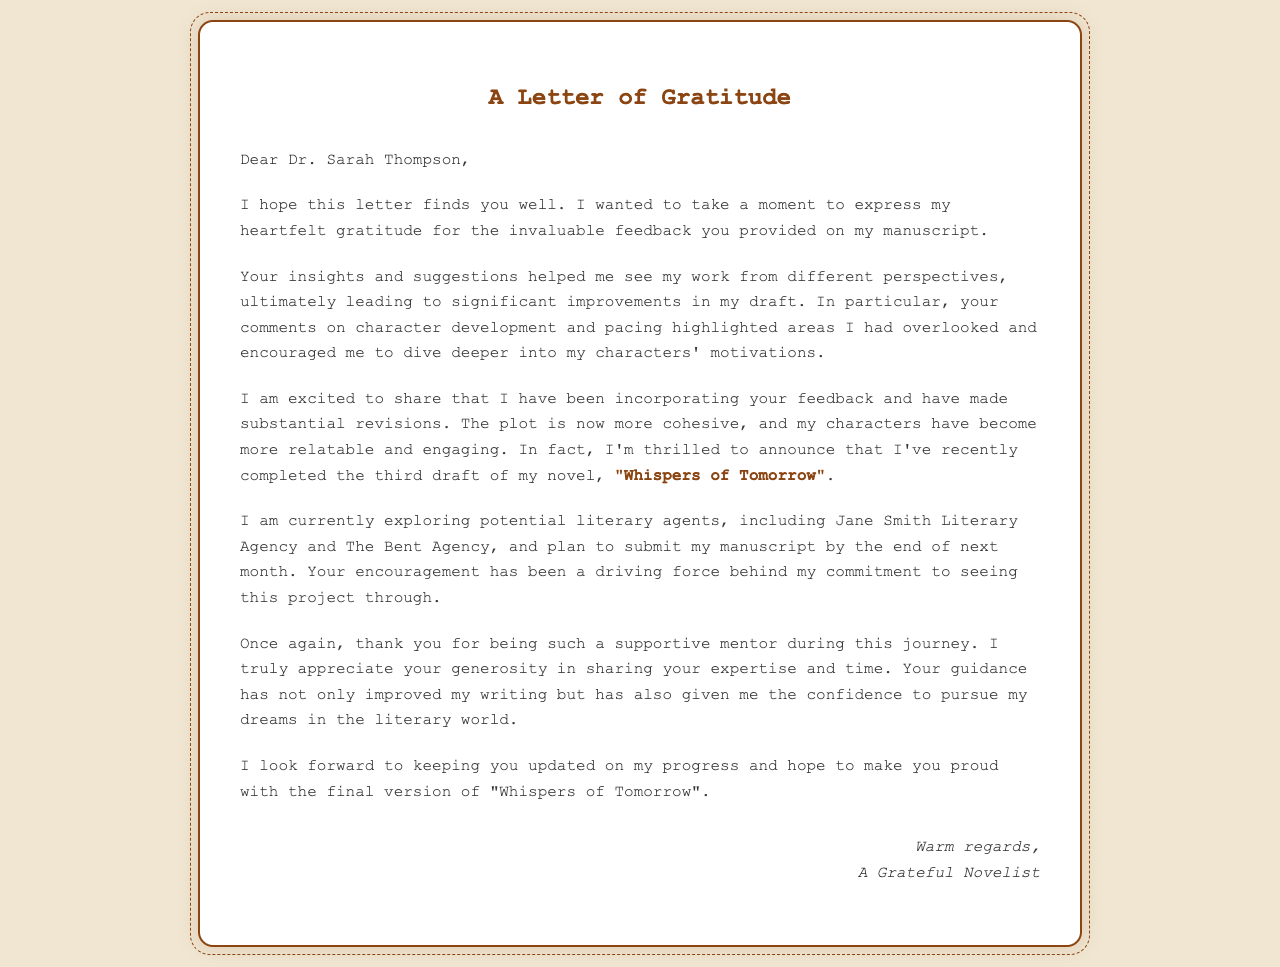What is the name of the mentor? The mentor's name is mentioned in the salutation of the letter.
Answer: Dr. Sarah Thompson What is the title of the manuscript? The title of the manuscript is highlighted in the document as part of the discussion about revisions.
Answer: "Whispers of Tomorrow" How many drafts of the novel have been completed? The letter states how many drafts have been completed, reflecting the author's progress.
Answer: third draft What agencies is the author exploring for representation? The author lists potential literary agencies that they are considering for submission.
Answer: Jane Smith Literary Agency and The Bent Agency What aspect of writing did the mentor's feedback mainly focus on? The letter identifies key aspects of writing that were highlighted by the mentor's feedback.
Answer: character development and pacing What sentiment does the author express towards the mentor's support? The author conveys a specific feeling towards the mentor's guidance and support throughout their writing journey.
Answer: gratitude When does the author plan to submit the manuscript? The letter specifies a timeline for submitting the manuscript based on the author's progress.
Answer: by the end of next month What does the author hope to achieve with the final version? The author expresses a hope associated with the end goal of their writing process.
Answer: make you proud with the final version 